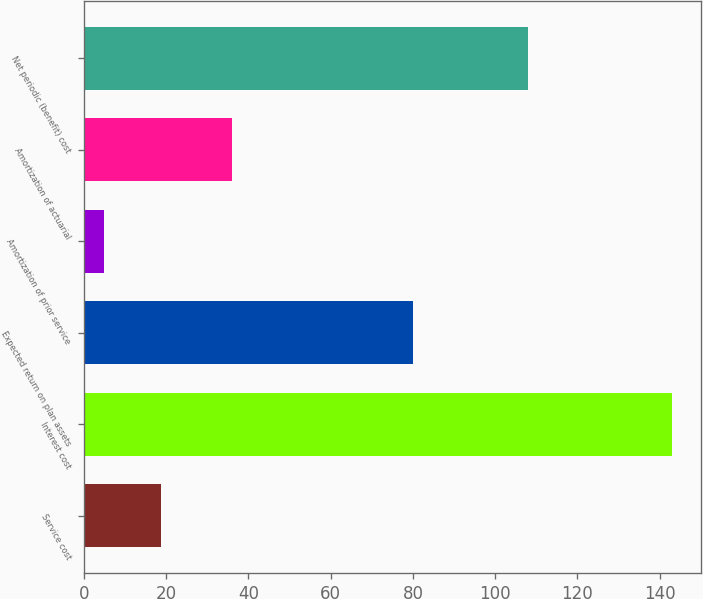Convert chart. <chart><loc_0><loc_0><loc_500><loc_500><bar_chart><fcel>Service cost<fcel>Interest cost<fcel>Expected return on plan assets<fcel>Amortization of prior service<fcel>Amortization of actuarial<fcel>Net periodic (benefit) cost<nl><fcel>18.8<fcel>143<fcel>80<fcel>5<fcel>36<fcel>108<nl></chart> 